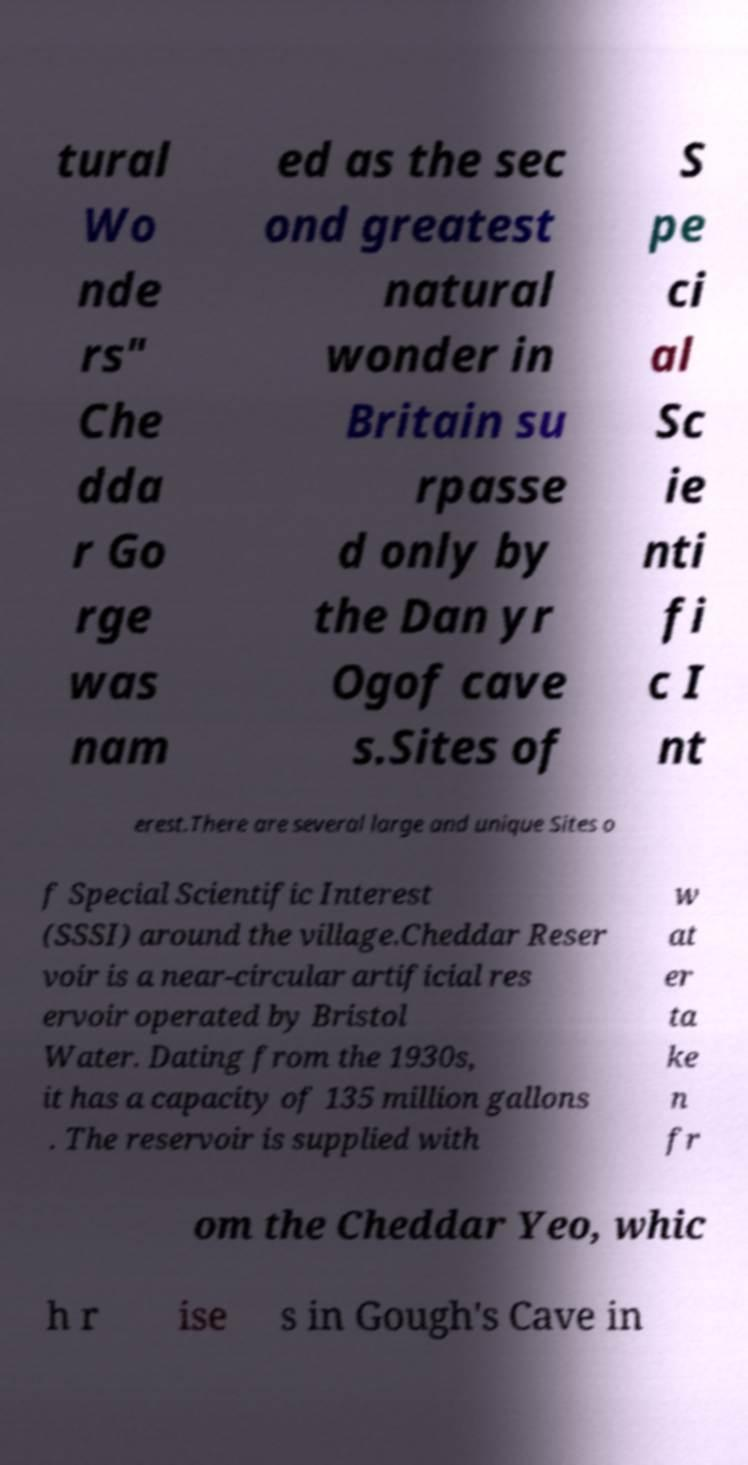There's text embedded in this image that I need extracted. Can you transcribe it verbatim? tural Wo nde rs" Che dda r Go rge was nam ed as the sec ond greatest natural wonder in Britain su rpasse d only by the Dan yr Ogof cave s.Sites of S pe ci al Sc ie nti fi c I nt erest.There are several large and unique Sites o f Special Scientific Interest (SSSI) around the village.Cheddar Reser voir is a near-circular artificial res ervoir operated by Bristol Water. Dating from the 1930s, it has a capacity of 135 million gallons . The reservoir is supplied with w at er ta ke n fr om the Cheddar Yeo, whic h r ise s in Gough's Cave in 